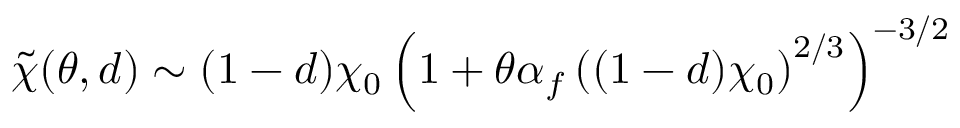Convert formula to latex. <formula><loc_0><loc_0><loc_500><loc_500>\tilde { \chi } ( \theta , d ) \sim ( 1 - d ) \chi _ { 0 } \left ( 1 + \theta \alpha _ { f } \left ( ( 1 - d ) \chi _ { 0 } \right ) ^ { 2 / 3 } \right ) ^ { - 3 / 2 }</formula> 